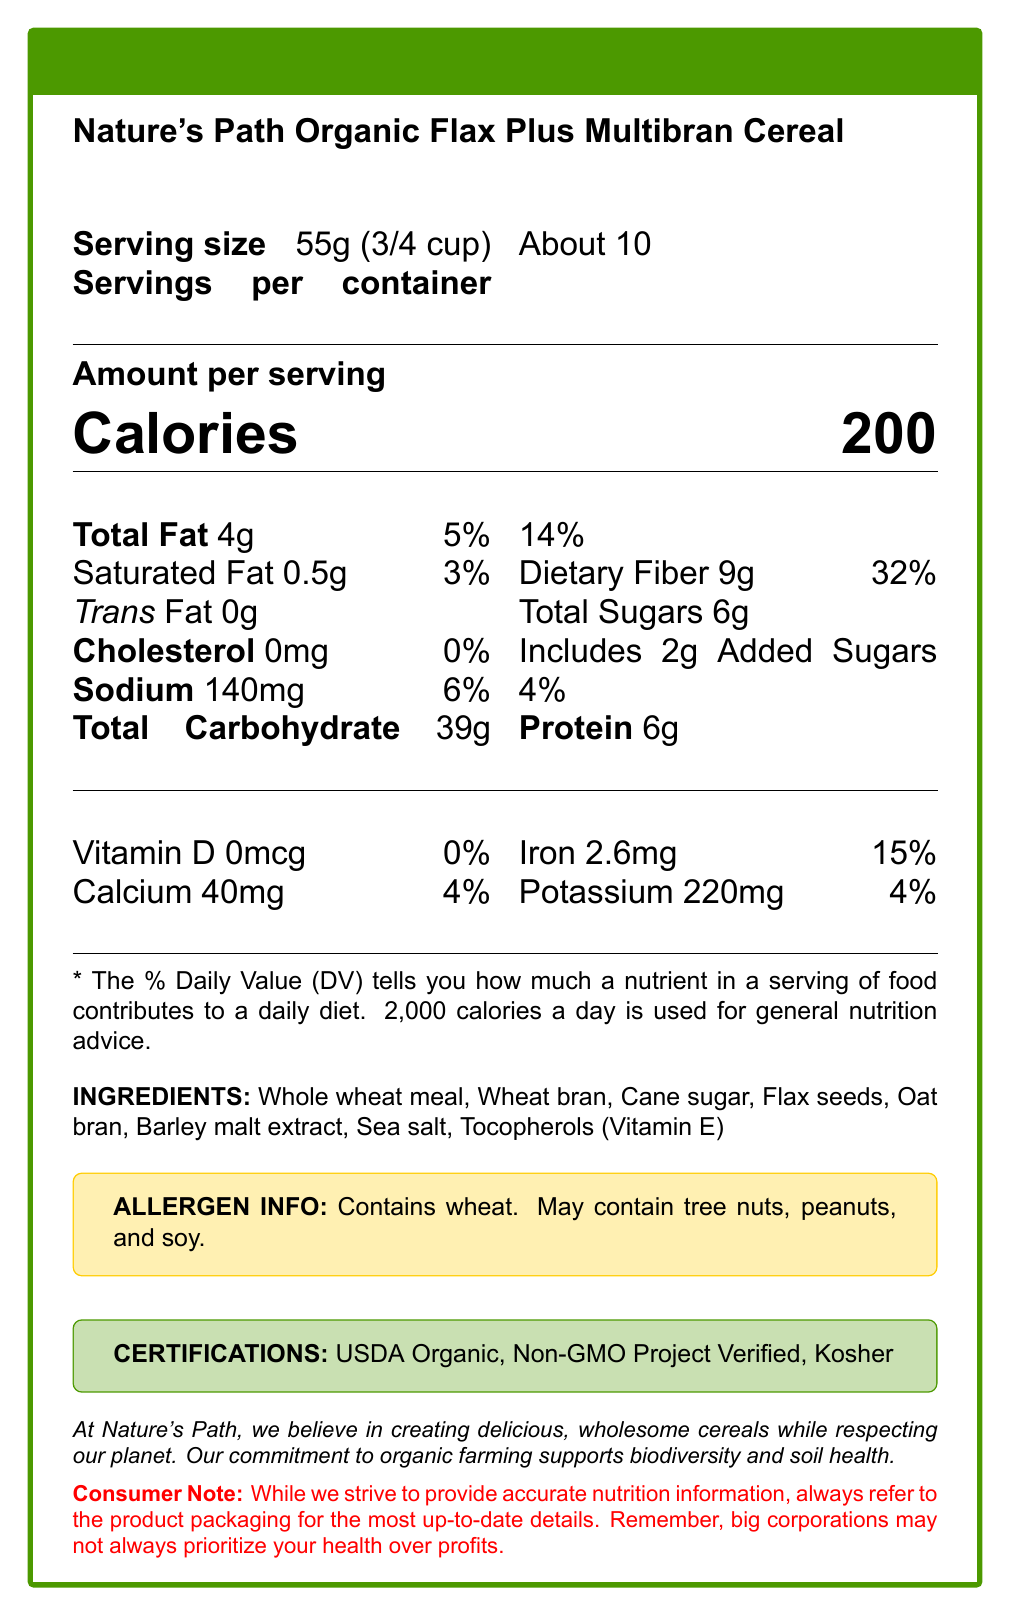What is the serving size of Nature's Path Organic Flax Plus Multibran Cereal? The serving size is clearly mentioned at the top of the Nutrition Facts label as "55g (3/4 cup)".
Answer: 55g (3/4 cup) How many calories are in a serving of the cereal? The Calories section in the document states there are 200 calories per serving.
Answer: 200 How much dietary fiber is in one serving of the cereal? The document specifies 9g of dietary fiber per serving, which is 32% of the daily value.
Answer: 9g What is the % Daily Value of iron provided by one serving? The iron content per serving is listed as 2.6mg, which equals 15% of the daily value.
Answer: 15% Which certification does Nature's Path Organic Flax Plus Multibran Cereal have? The document lists three certifications: USDA Organic, Non-GMO Project Verified, and Kosher.
Answer: USDA Organic, Non-GMO Project Verified, Kosher How much added sugar is in one serving? The label indicates that there are 2g of added sugars, making up 4% of the daily value.
Answer: 2g Does this cereal contain any cholesterol? The Nutrition Facts label indicates that there is 0mg of cholesterol in the cereal.
Answer: No Are there any potential allergens in the cereal? The allergen information in the document states that it contains wheat and might contain tree nuts, peanuts, and soy.
Answer: Yes What ingredients are used in this cereal? List down at least three. The ingredients section lists several components, including whole wheat meal, wheat bran, and cane sugar among others.
Answer: Whole wheat meal, Wheat bran, Cane sugar Does the cereal contain any trans fat? The Nutrition Facts label specifies that the cereal contains 0g trans fat.
Answer: No Which of the following correctly lists all the certifications of this cereal? A. USDA Organic, Non-GMO Project Verified, Kosher B. USDA Organic, Gluten-Free, Kosher C. Non-GMO Project Verified, Gluten-Free, Vegan The document lists the certifications as USDA Organic, Non-GMO Project Verified, and Kosher.
Answer: A. USDA Organic, Non-GMO Project Verified, Kosher What is the total carbohydrate content per serving? A. 20g B. 30g C. 39g D. 25g The Nutrition Facts label indicates that the total carbohydrate content per serving is 39g.
Answer: C. 39g Does the cereal provide any Vitamin D? According to the document, the cereal has 0mcg of Vitamin D, which is 0% of the daily value.
Answer: No Summarize the main nutritional highlights of Nature's Path Organic Flax Plus Multibran Cereal. The cereal contains 9g dietary fiber per serving (32% daily value), only 2g added sugars (4% daily value), and is certified USDA Organic and Non-GMO Project Verified.
Answer: High in fiber, low in added sugars, certified organic, non-GMO Can we determine the production date of the cereal from this document? The document does not provide any details regarding the production or expiration date of the cereal.
Answer: Not enough information 